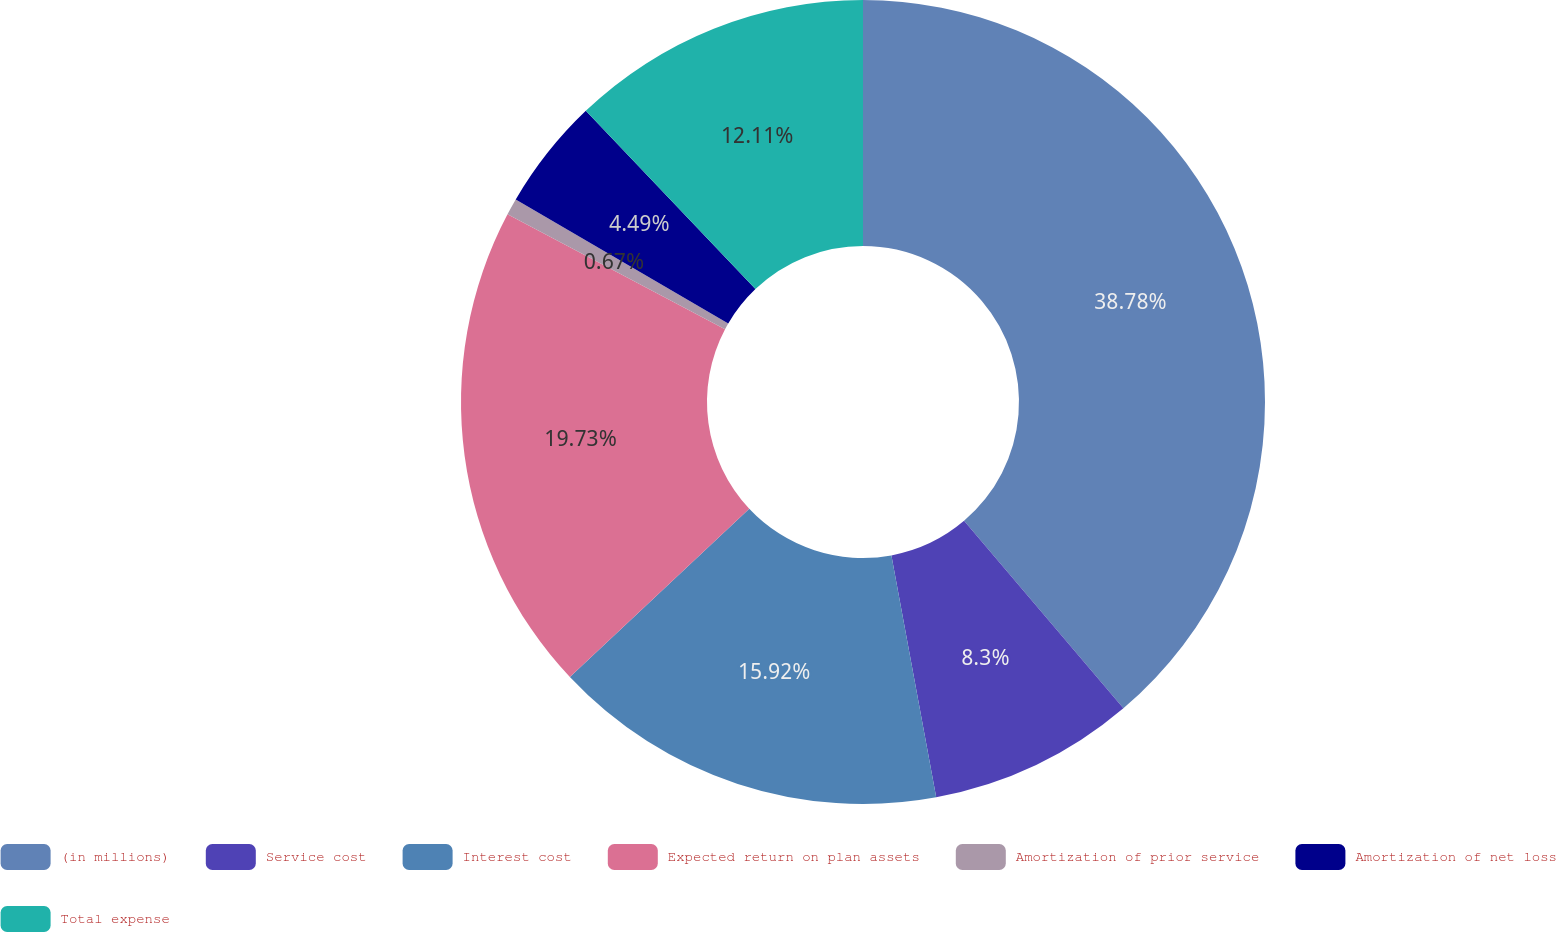<chart> <loc_0><loc_0><loc_500><loc_500><pie_chart><fcel>(in millions)<fcel>Service cost<fcel>Interest cost<fcel>Expected return on plan assets<fcel>Amortization of prior service<fcel>Amortization of net loss<fcel>Total expense<nl><fcel>38.79%<fcel>8.3%<fcel>15.92%<fcel>19.73%<fcel>0.67%<fcel>4.49%<fcel>12.11%<nl></chart> 